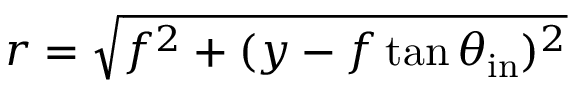Convert formula to latex. <formula><loc_0><loc_0><loc_500><loc_500>r = \sqrt { f ^ { 2 } + ( y - f \tan { \theta _ { i n } } ) ^ { 2 } }</formula> 